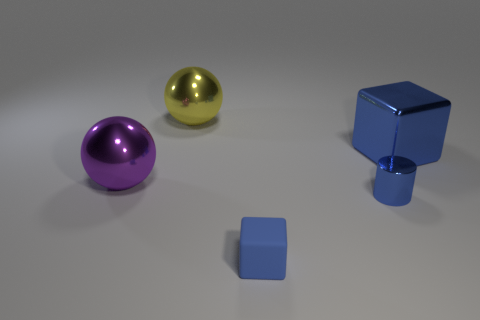Is there any other thing that is the same material as the small cube?
Your response must be concise. No. There is a blue object that is left of the tiny metal cylinder; is there a tiny blue block that is in front of it?
Make the answer very short. No. Are there fewer small matte blocks in front of the tiny blue rubber cube than blue blocks behind the metal cylinder?
Keep it short and to the point. Yes. There is a blue object that is in front of the small blue thing that is behind the blue object that is in front of the small blue cylinder; what size is it?
Ensure brevity in your answer.  Small. There is a ball that is behind the purple metallic sphere; does it have the same size as the rubber thing?
Provide a succinct answer. No. How many other things are made of the same material as the tiny blue cube?
Your answer should be compact. 0. Are there more small gray metal cylinders than blue rubber objects?
Ensure brevity in your answer.  No. What material is the sphere behind the blue cube to the right of the blue object in front of the tiny blue cylinder?
Your answer should be compact. Metal. Do the tiny matte block and the small cylinder have the same color?
Make the answer very short. Yes. Are there any metal cylinders that have the same color as the matte cube?
Provide a succinct answer. Yes. 